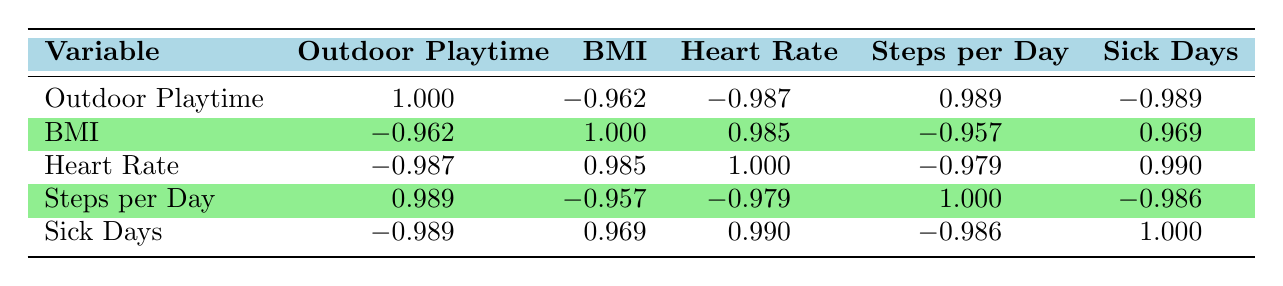What is the correlation coefficient between outdoor playtime and BMI? The table shows that the correlation coefficient between outdoor playtime and BMI is -0.962.
Answer: -0.962 What is the relationship between outdoor playtime and sick days? According to the table, the correlation coefficient between outdoor playtime and sick days is -0.989, indicating an inverse relationship. More outdoor playtime is associated with fewer sick days.
Answer: -0.989 What is the correlation between steps per day and heart rate? The table indicates a correlation coefficient of -0.979 between steps per day and heart rate, suggesting that as the steps per day increase, the heart rate tends to decrease.
Answer: -0.979 What would be the average BMI of children with more than 4 hours of outdoor play? The BMI values for children with more than 4 hours of outdoor play are 16.2 (5 hours), 15.8 (6 hours), and 15.5 (7 hours), giving a sum of 16.2 + 15.8 + 15.5 = 47.5. There are 3 data points, so the average is 47.5 / 3 = 15.83.
Answer: 15.83 Is there a positive correlation between steps per day and outdoor playtime? Yes, the correlation coefficient for steps per day and outdoor playtime is 0.989, indicating a strong positive correlation. As outdoor playtime increases, steps per day also increase.
Answer: Yes What is the total number of sick days for the child with the highest outdoor playtime? The child with the highest outdoor playtime is child_id 7, who has 0 sick days.
Answer: 0 How many sick days did the child with the lowest BMI have? The child with the lowest BMI is child_id 7 with a BMI of 15.5, and this child has 0 sick days.
Answer: 0 What is the correlation between heart rate and BMI? The table shows that the correlation coefficient between heart rate and BMI is 0.985, indicating a strong positive correlation between these two variables.
Answer: 0.985 